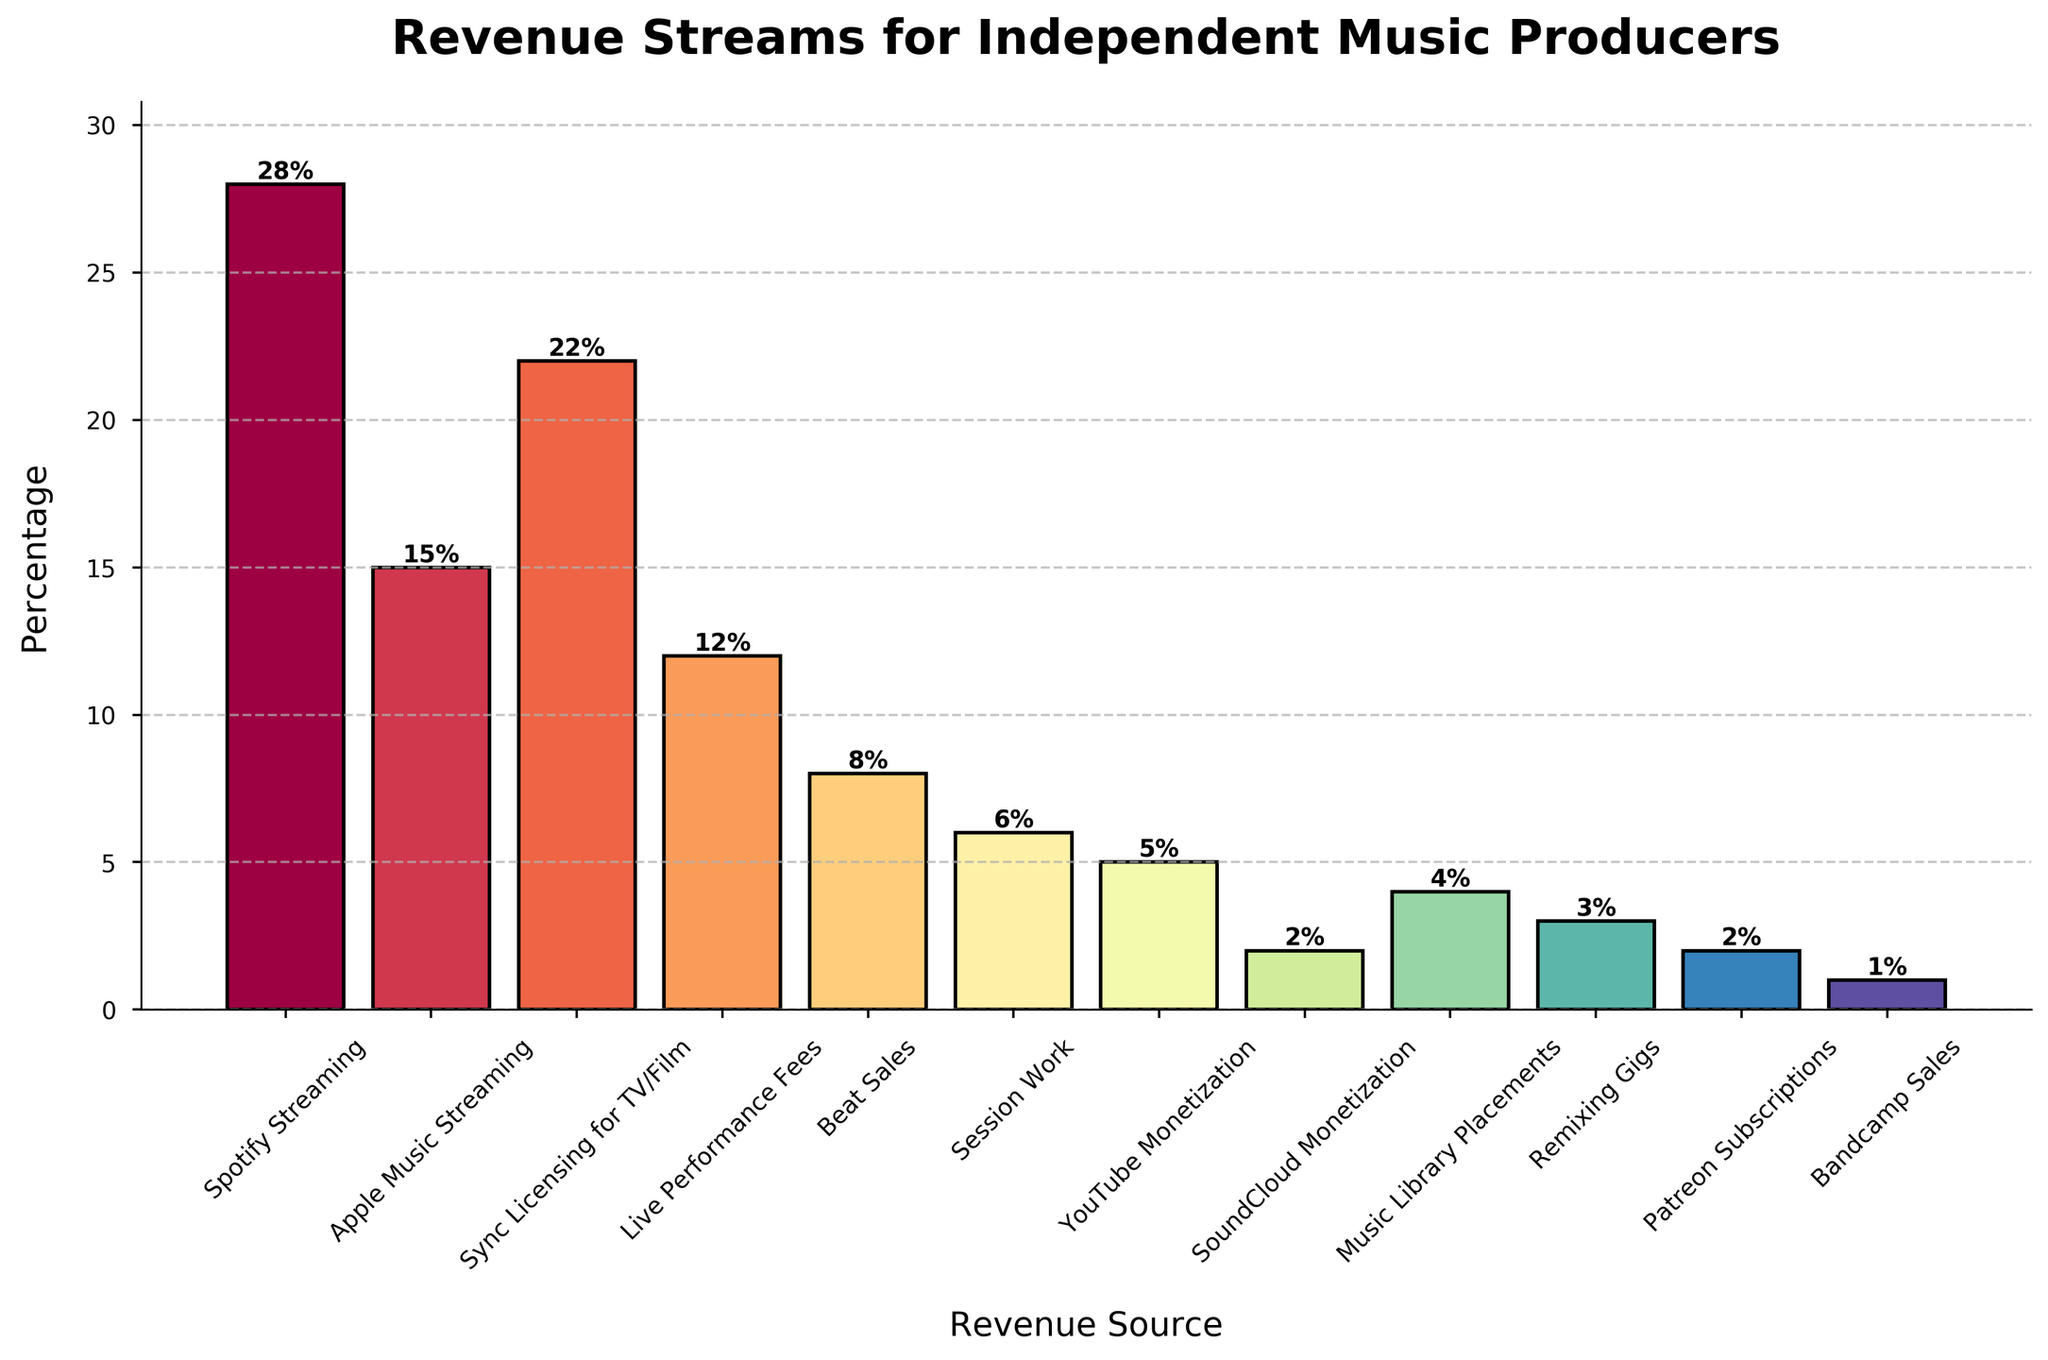What percentage of revenue comes from streaming sources (Spotify and Apple Music)? Add the percentages for Spotify Streaming (28%) and Apple Music Streaming (15%) to get the total revenue from streaming sources. 28% + 15% = 43%
Answer: 43% What is the difference in revenue percentages between Sync Licensing for TV/Film and Live Performance Fees? Subtract the percentage for Live Performance Fees (12%) from the percentage for Sync Licensing for TV/Film (22%). 22% - 12% = 10%
Answer: 10% Which revenue source is the least? The revenue source with the smallest percentage is Bandcamp Sales, which is 1%.
Answer: Bandcamp Sales What is the total revenue percentage of all sources combined that contribute less than 5% each? Add the percentages for Session Work (6%), YouTube Monetization (5%), SoundCloud Monetization (2%), Music Library Placements (4%), Remixing Gigs (3%), Patreon Subscriptions (2%), and Bandcamp Sales (1%). 6% + 5% + 2% + 4% + 3% + 2% + 1% = 23%
Answer: 23% Which revenue source has the highest percentage? The revenue source with the highest percentage is Spotify Streaming at 28%.
Answer: Spotify Streaming Compare the total revenue from Sync Licensing for TV/Film and Beat Sales. Which one is higher, and by how much? Sync Licensing for TV/Film is 22% and Beat Sales is 8%. Sync Licensing is higher. Calculate the difference by subtracting Beat Sales from Sync Licensing: 22% - 8% = 14%
Answer: Sync Licensing is higher by 14% What is the combined percentage of revenue from live sources (Live Performance Fees and Remixing Gigs)? Add the percentages for Live Performance Fees (12%) and Remixing Gigs (3%) to get the total revenue from live sources. 12% + 3% = 15%
Answer: 15% What is the visual appearance (color) of the bar representing YouTube Monetization? YouTube Monetization is near the bottom of the chart with a small percentage, likely represented with a color closer to the lower end of the spectral colormap.
Answer: Color near the lower end of the spectral colormap (e.g., darker shades) How many revenue sources contribute exactly 2% to the total revenue? There are two revenue sources with 2% each: SoundCloud Monetization and Patreon Subscriptions.
Answer: 2 Which revenue source has a slightly higher percentage, Beat Sales or Session Work? Beat Sales has a percentage of 8%, whereas Session Work has 6%. Beat Sales is 2% higher.
Answer: Beat Sales 